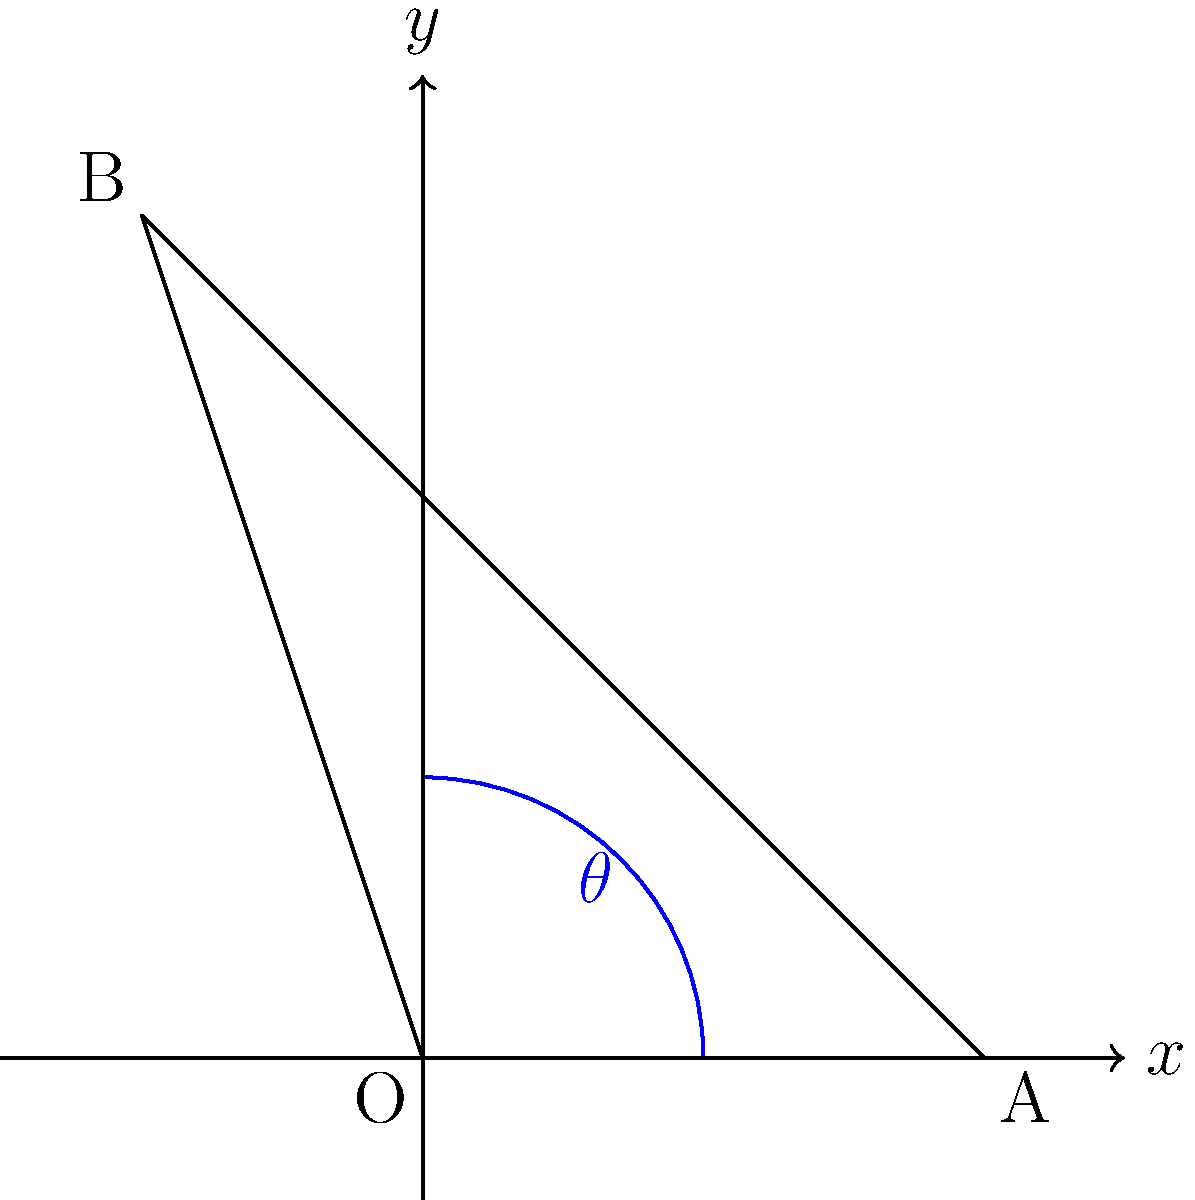During a football match, Wale Musa Alli observes a player kicking the ball. The player's leg forms a triangle with the ground, where the knee angle (θ) is crucial for the kick's power. If the coordinates of the player's hip (O), foot (A), and knee (B) are (0,0), (2,0), and (-1,3) respectively on a coordinate plane where each unit represents 0.5 meters, what is the approximate angle of knee flexion (θ) in degrees? To find the angle of knee flexion (θ), we need to follow these steps:

1. Identify the triangle formed by the hip (O), knee (B), and foot (A).
2. Calculate the lengths of the sides OB and BA using the distance formula:
   $d = \sqrt{(x_2-x_1)^2 + (y_2-y_1)^2}$

   OB: $\sqrt{(-1-0)^2 + (3-0)^2} = \sqrt{10}$
   BA: $\sqrt{(-1-2)^2 + (3-0)^2} = \sqrt{18}$

3. Use the law of cosines to find the angle θ:
   $\cos(\theta) = \frac{OA^2 + OB^2 - BA^2}{2 \cdot OA \cdot OB}$

   Where OA = 2 (from the given coordinates)

4. Substitute the values:
   $\cos(\theta) = \frac{2^2 + 10 - 18}{2 \cdot 2 \cdot \sqrt{10}}$

5. Simplify:
   $\cos(\theta) = \frac{-4}{4\sqrt{10}} = -\frac{1}{\sqrt{10}}$

6. Take the inverse cosine (arccos) of both sides:
   $\theta = \arccos(-\frac{1}{\sqrt{10}})$

7. Calculate the result:
   $\theta \approx 108.2°$

Therefore, the approximate angle of knee flexion is 108°.
Answer: 108° 